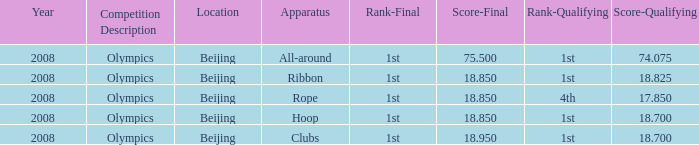Which apparatus saw kanayeva's final score not exceed 75.5 and her qualifying score remain under 18.7? Rope. 